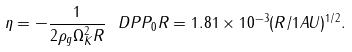<formula> <loc_0><loc_0><loc_500><loc_500>\eta = - \frac { 1 } { 2 \rho _ { g } \Omega _ { K } ^ { 2 } R } \ D P { P _ { 0 } } { R } = 1 . 8 1 \times 1 0 ^ { - 3 } ( R / 1 A U ) ^ { 1 / 2 } .</formula> 